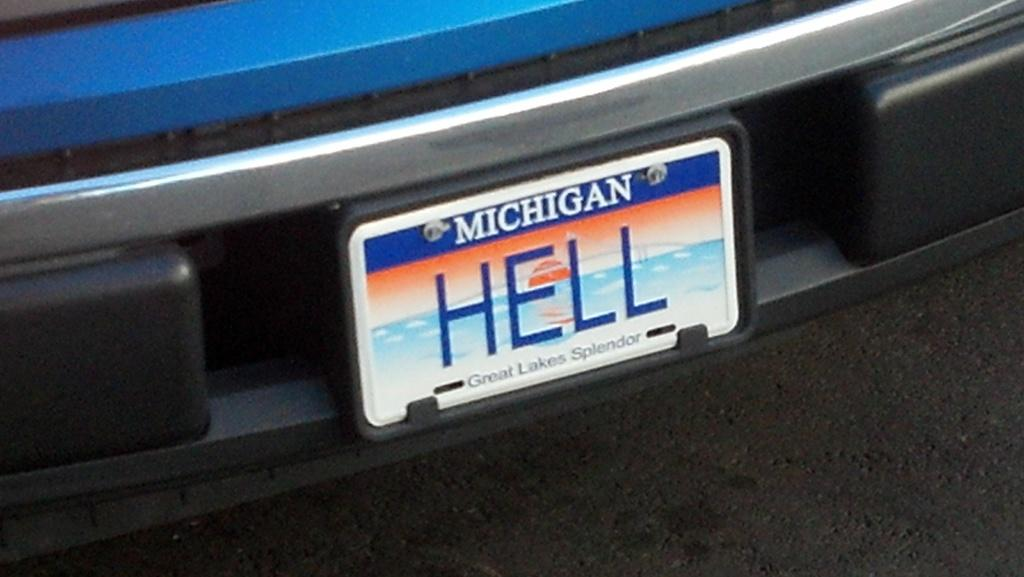Provide a one-sentence caption for the provided image. The bumper of a blue car with a Michigan tag on it that says Hell. 